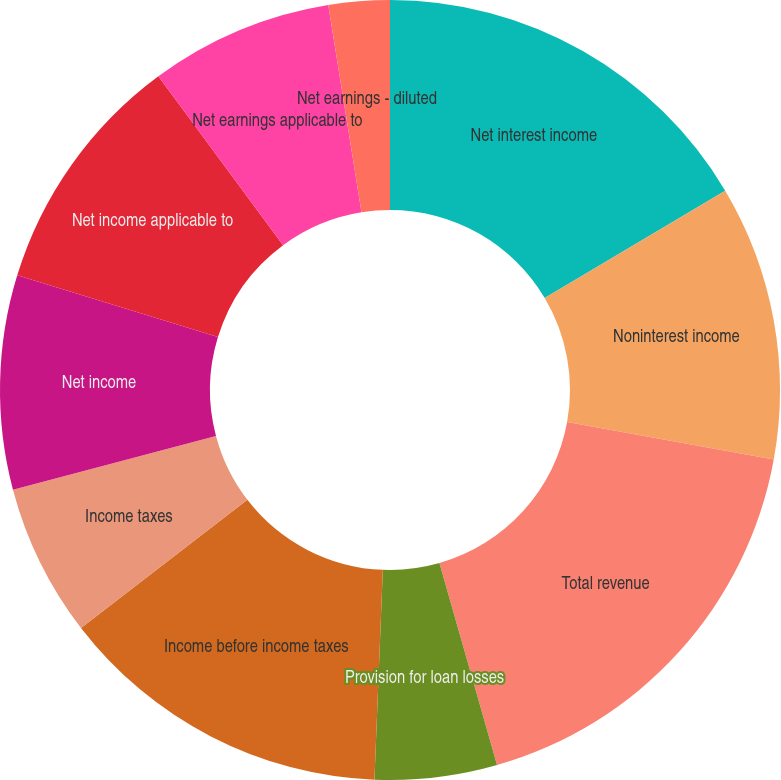Convert chart to OTSL. <chart><loc_0><loc_0><loc_500><loc_500><pie_chart><fcel>Net interest income<fcel>Noninterest income<fcel>Total revenue<fcel>Provision for loan losses<fcel>Income before income taxes<fcel>Income taxes<fcel>Net income<fcel>Net income applicable to<fcel>Net earnings applicable to<fcel>Net earnings - diluted<nl><fcel>16.46%<fcel>11.39%<fcel>17.72%<fcel>5.06%<fcel>13.92%<fcel>6.33%<fcel>8.86%<fcel>10.13%<fcel>7.59%<fcel>2.53%<nl></chart> 